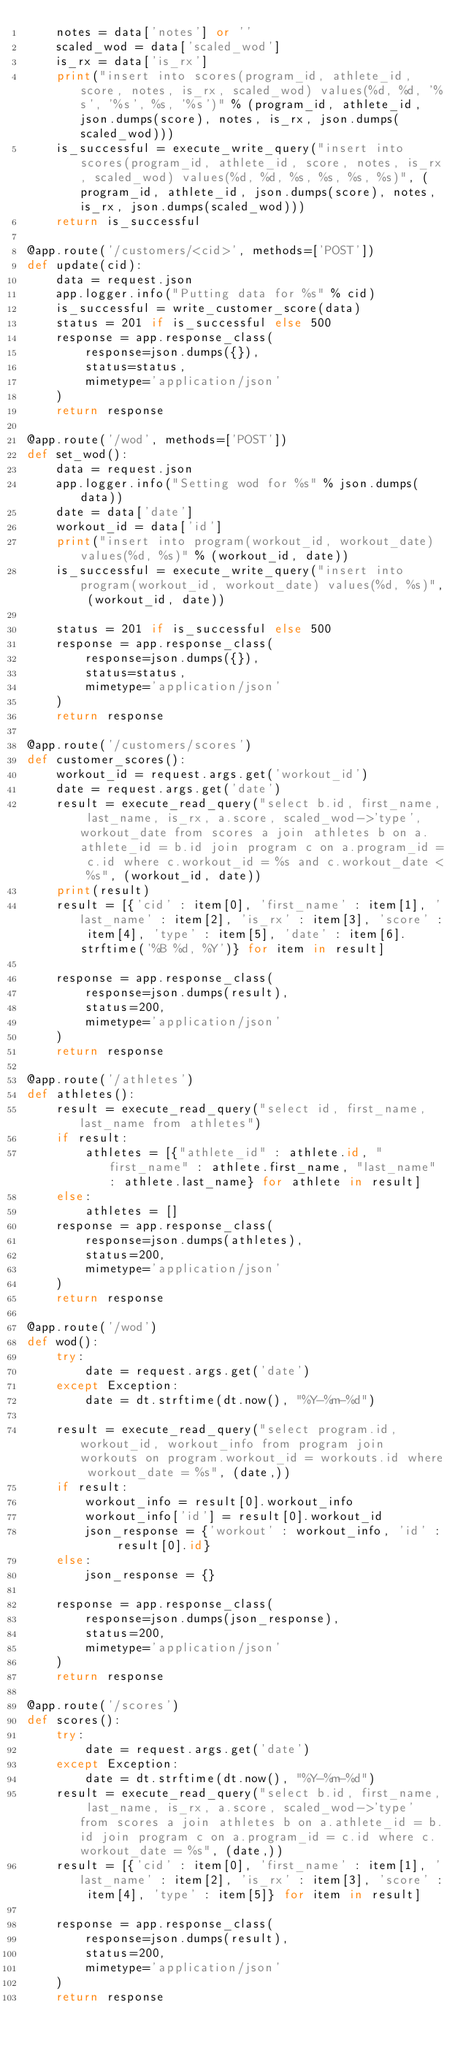Convert code to text. <code><loc_0><loc_0><loc_500><loc_500><_Python_>    notes = data['notes'] or ''
    scaled_wod = data['scaled_wod']
    is_rx = data['is_rx'] 
    print("insert into scores(program_id, athlete_id, score, notes, is_rx, scaled_wod) values(%d, %d, '%s', '%s', %s, '%s')" % (program_id, athlete_id, json.dumps(score), notes, is_rx, json.dumps(scaled_wod)))
    is_successful = execute_write_query("insert into scores(program_id, athlete_id, score, notes, is_rx, scaled_wod) values(%d, %d, %s, %s, %s, %s)", (program_id, athlete_id, json.dumps(score), notes, is_rx, json.dumps(scaled_wod)))
    return is_successful

@app.route('/customers/<cid>', methods=['POST'])
def update(cid):
    data = request.json
    app.logger.info("Putting data for %s" % cid)
    is_successful = write_customer_score(data)
    status = 201 if is_successful else 500
    response = app.response_class(
        response=json.dumps({}),
        status=status,
        mimetype='application/json'
    )
    return response 

@app.route('/wod', methods=['POST'])
def set_wod():
    data = request.json
    app.logger.info("Setting wod for %s" % json.dumps(data))
    date = data['date']
    workout_id = data['id']
    print("insert into program(workout_id, workout_date) values(%d, %s)" % (workout_id, date))
    is_successful = execute_write_query("insert into program(workout_id, workout_date) values(%d, %s)", (workout_id, date))
    
    status = 201 if is_successful else 500
    response = app.response_class(
        response=json.dumps({}),
        status=status,
        mimetype='application/json'
    )
    return response 

@app.route('/customers/scores')
def customer_scores():
    workout_id = request.args.get('workout_id')
    date = request.args.get('date')
    result = execute_read_query("select b.id, first_name, last_name, is_rx, a.score, scaled_wod->'type', workout_date from scores a join athletes b on a.athlete_id = b.id join program c on a.program_id = c.id where c.workout_id = %s and c.workout_date < %s", (workout_id, date))
    print(result)
    result = [{'cid' : item[0], 'first_name' : item[1], 'last_name' : item[2], 'is_rx' : item[3], 'score' : item[4], 'type' : item[5], 'date' : item[6].strftime('%B %d, %Y')} for item in result]
    
    response = app.response_class(
        response=json.dumps(result),
        status=200,
        mimetype='application/json'
    )
    return response

@app.route('/athletes')
def athletes():
    result = execute_read_query("select id, first_name, last_name from athletes")
    if result:
        athletes = [{"athlete_id" : athlete.id, "first_name" : athlete.first_name, "last_name" : athlete.last_name} for athlete in result]
    else:
        athletes = []
    response = app.response_class(
        response=json.dumps(athletes),
        status=200,
        mimetype='application/json'
    )
    return response 

@app.route('/wod')
def wod():
    try:
        date = request.args.get('date')
    except Exception:
        date = dt.strftime(dt.now(), "%Y-%m-%d")

    result = execute_read_query("select program.id, workout_id, workout_info from program join workouts on program.workout_id = workouts.id where workout_date = %s", (date,))
    if result:
        workout_info = result[0].workout_info
        workout_info['id'] = result[0].workout_id
        json_response = {'workout' : workout_info, 'id' : result[0].id} 
    else:
        json_response = {}

    response = app.response_class(
        response=json.dumps(json_response),
        status=200,
        mimetype='application/json'
    )
    return response

@app.route('/scores')
def scores():
    try:
        date = request.args.get('date')
    except Exception:
        date = dt.strftime(dt.now(), "%Y-%m-%d")
    result = execute_read_query("select b.id, first_name, last_name, is_rx, a.score, scaled_wod->'type' from scores a join athletes b on a.athlete_id = b.id join program c on a.program_id = c.id where c.workout_date = %s", (date,))
    result = [{'cid' : item[0], 'first_name' : item[1], 'last_name' : item[2], 'is_rx' : item[3], 'score' : item[4], 'type' : item[5]} for item in result]
    
    response = app.response_class(
        response=json.dumps(result),
        status=200,
        mimetype='application/json'
    )
    return response
</code> 